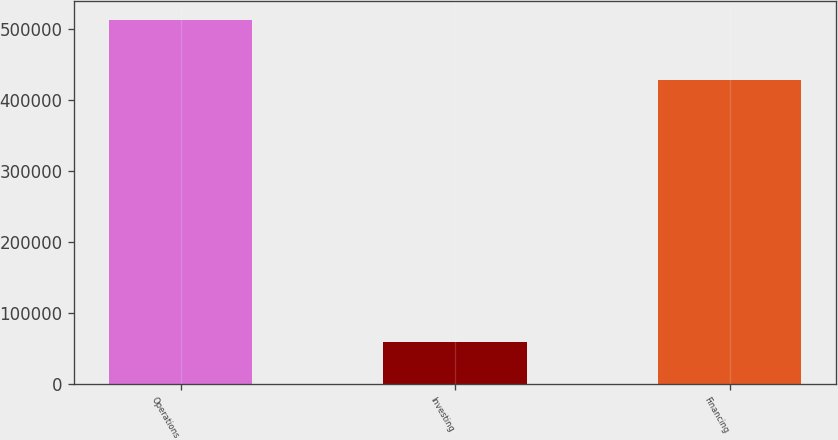<chart> <loc_0><loc_0><loc_500><loc_500><bar_chart><fcel>Operations<fcel>Investing<fcel>Financing<nl><fcel>513793<fcel>58410<fcel>427915<nl></chart> 